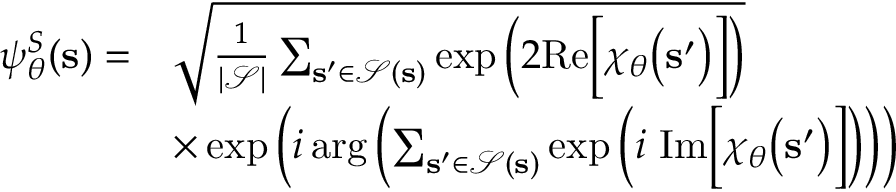<formula> <loc_0><loc_0><loc_500><loc_500>\begin{array} { r l } { \psi _ { \boldsymbol \theta } ^ { S } ( s ) = } & { \sqrt { \frac { 1 } { | \mathcal { S } | } \sum _ { s ^ { \prime } \in \mathcal { S } ( s ) } \exp \left ( 2 R e \left [ \chi _ { \boldsymbol \theta } \left ( s ^ { \prime } \right ) \right ] \right ) } } \\ & { \times \exp \left ( i \arg \left ( \sum _ { s ^ { \prime } \in \mathcal { S } ( s ) } \exp \left ( i \ I m \left [ \chi _ { \boldsymbol \theta } \left ( s ^ { \prime } \right ) \right ] \right ) \right ) \right ) } \end{array}</formula> 